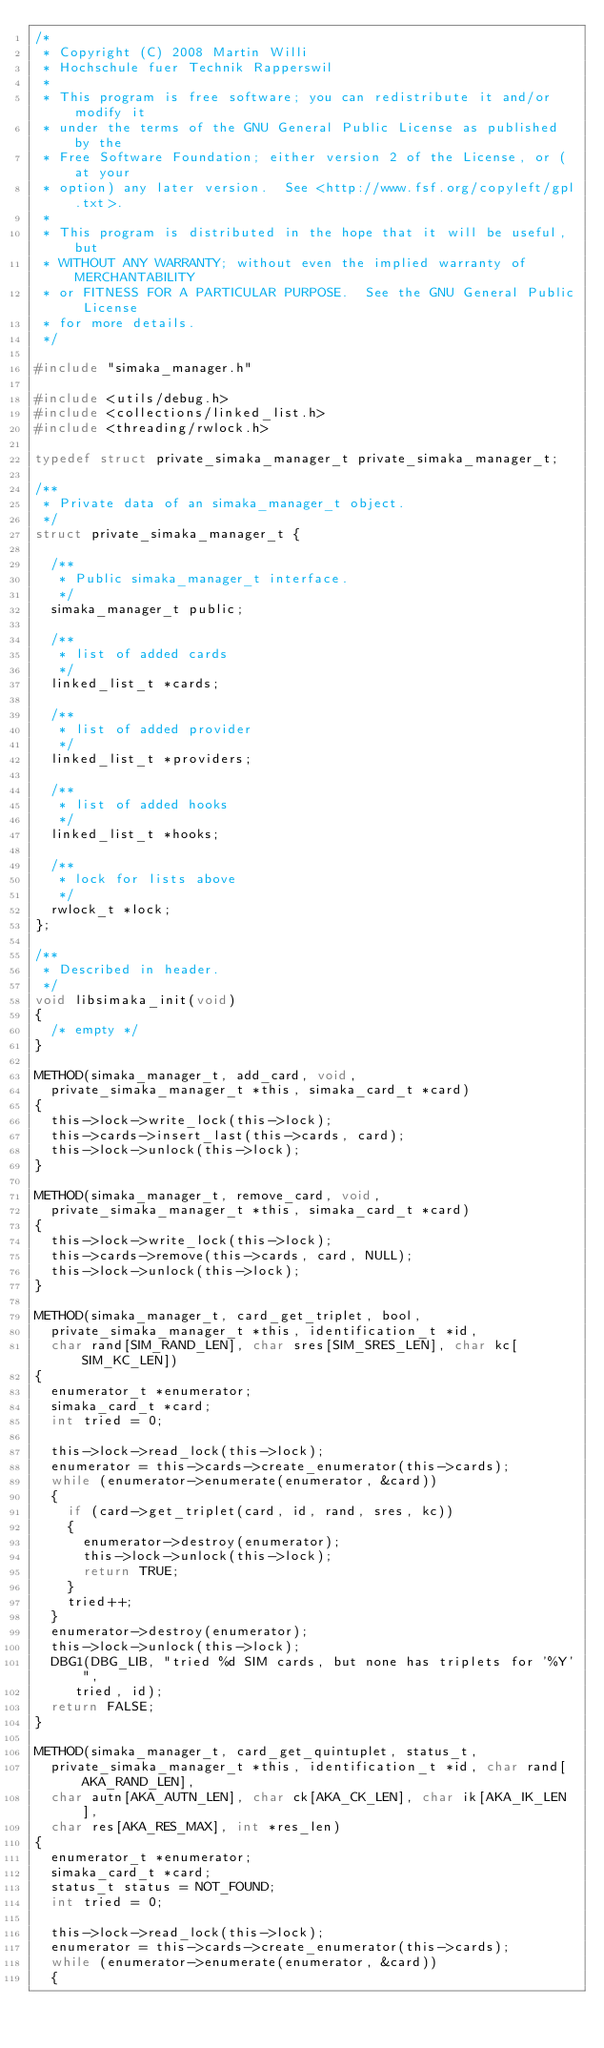Convert code to text. <code><loc_0><loc_0><loc_500><loc_500><_C_>/*
 * Copyright (C) 2008 Martin Willi
 * Hochschule fuer Technik Rapperswil
 *
 * This program is free software; you can redistribute it and/or modify it
 * under the terms of the GNU General Public License as published by the
 * Free Software Foundation; either version 2 of the License, or (at your
 * option) any later version.  See <http://www.fsf.org/copyleft/gpl.txt>.
 *
 * This program is distributed in the hope that it will be useful, but
 * WITHOUT ANY WARRANTY; without even the implied warranty of MERCHANTABILITY
 * or FITNESS FOR A PARTICULAR PURPOSE.  See the GNU General Public License
 * for more details.
 */

#include "simaka_manager.h"

#include <utils/debug.h>
#include <collections/linked_list.h>
#include <threading/rwlock.h>

typedef struct private_simaka_manager_t private_simaka_manager_t;

/**
 * Private data of an simaka_manager_t object.
 */
struct private_simaka_manager_t {

	/**
	 * Public simaka_manager_t interface.
	 */
	simaka_manager_t public;

	/**
	 * list of added cards
	 */
	linked_list_t *cards;

	/**
	 * list of added provider
	 */
	linked_list_t *providers;

	/**
	 * list of added hooks
	 */
	linked_list_t *hooks;

	/**
	 * lock for lists above
	 */
	rwlock_t *lock;
};

/**
 * Described in header.
 */
void libsimaka_init(void)
{
	/* empty */
}

METHOD(simaka_manager_t, add_card, void,
	private_simaka_manager_t *this, simaka_card_t *card)
{
	this->lock->write_lock(this->lock);
	this->cards->insert_last(this->cards, card);
	this->lock->unlock(this->lock);
}

METHOD(simaka_manager_t, remove_card, void,
	private_simaka_manager_t *this, simaka_card_t *card)
{
	this->lock->write_lock(this->lock);
	this->cards->remove(this->cards, card, NULL);
	this->lock->unlock(this->lock);
}

METHOD(simaka_manager_t, card_get_triplet, bool,
	private_simaka_manager_t *this, identification_t *id,
	char rand[SIM_RAND_LEN], char sres[SIM_SRES_LEN], char kc[SIM_KC_LEN])
{
	enumerator_t *enumerator;
	simaka_card_t *card;
	int tried = 0;

	this->lock->read_lock(this->lock);
	enumerator = this->cards->create_enumerator(this->cards);
	while (enumerator->enumerate(enumerator, &card))
	{
		if (card->get_triplet(card, id, rand, sres, kc))
		{
			enumerator->destroy(enumerator);
			this->lock->unlock(this->lock);
			return TRUE;
		}
		tried++;
	}
	enumerator->destroy(enumerator);
	this->lock->unlock(this->lock);
	DBG1(DBG_LIB, "tried %d SIM cards, but none has triplets for '%Y'",
		 tried, id);
	return FALSE;
}

METHOD(simaka_manager_t, card_get_quintuplet, status_t,
	private_simaka_manager_t *this, identification_t *id, char rand[AKA_RAND_LEN],
	char autn[AKA_AUTN_LEN], char ck[AKA_CK_LEN], char ik[AKA_IK_LEN],
	char res[AKA_RES_MAX], int *res_len)
{
	enumerator_t *enumerator;
	simaka_card_t *card;
	status_t status = NOT_FOUND;
	int tried = 0;

	this->lock->read_lock(this->lock);
	enumerator = this->cards->create_enumerator(this->cards);
	while (enumerator->enumerate(enumerator, &card))
	{</code> 